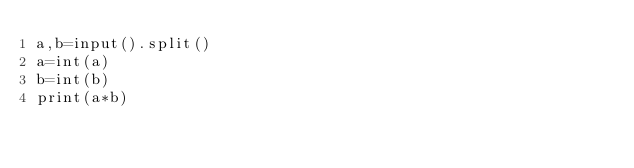Convert code to text. <code><loc_0><loc_0><loc_500><loc_500><_Python_>a,b=input().split()
a=int(a)
b=int(b)
print(a*b)</code> 